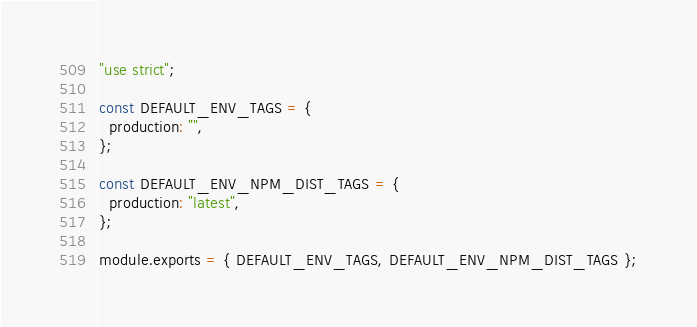Convert code to text. <code><loc_0><loc_0><loc_500><loc_500><_JavaScript_>"use strict";

const DEFAULT_ENV_TAGS = {
  production: "",
};

const DEFAULT_ENV_NPM_DIST_TAGS = {
  production: "latest",
};

module.exports = { DEFAULT_ENV_TAGS, DEFAULT_ENV_NPM_DIST_TAGS };
</code> 